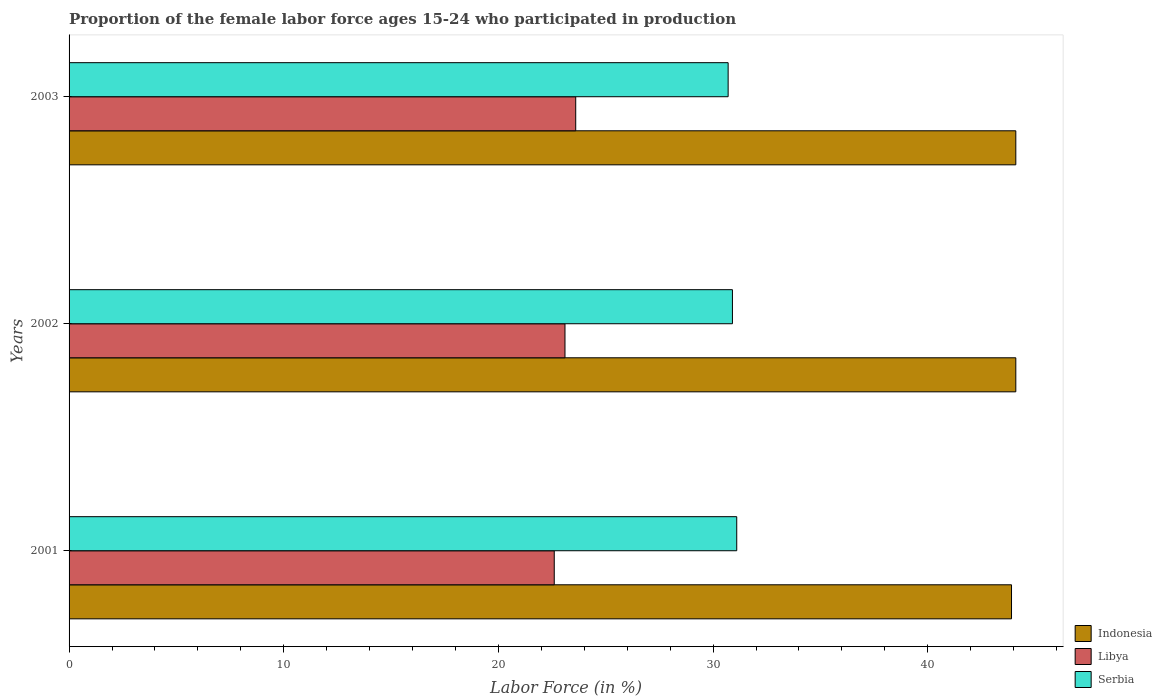How many groups of bars are there?
Provide a succinct answer. 3. Are the number of bars per tick equal to the number of legend labels?
Offer a terse response. Yes. How many bars are there on the 1st tick from the top?
Provide a short and direct response. 3. How many bars are there on the 1st tick from the bottom?
Offer a very short reply. 3. In how many cases, is the number of bars for a given year not equal to the number of legend labels?
Your response must be concise. 0. What is the proportion of the female labor force who participated in production in Libya in 2003?
Keep it short and to the point. 23.6. Across all years, what is the maximum proportion of the female labor force who participated in production in Serbia?
Offer a terse response. 31.1. Across all years, what is the minimum proportion of the female labor force who participated in production in Indonesia?
Your response must be concise. 43.9. In which year was the proportion of the female labor force who participated in production in Libya minimum?
Ensure brevity in your answer.  2001. What is the total proportion of the female labor force who participated in production in Libya in the graph?
Provide a short and direct response. 69.3. What is the difference between the proportion of the female labor force who participated in production in Libya in 2001 and that in 2003?
Provide a short and direct response. -1. What is the difference between the proportion of the female labor force who participated in production in Indonesia in 2001 and the proportion of the female labor force who participated in production in Libya in 2003?
Offer a very short reply. 20.3. What is the average proportion of the female labor force who participated in production in Serbia per year?
Your response must be concise. 30.9. In the year 2002, what is the difference between the proportion of the female labor force who participated in production in Serbia and proportion of the female labor force who participated in production in Indonesia?
Your answer should be very brief. -13.2. What is the ratio of the proportion of the female labor force who participated in production in Indonesia in 2001 to that in 2003?
Offer a very short reply. 1. Is the difference between the proportion of the female labor force who participated in production in Serbia in 2001 and 2003 greater than the difference between the proportion of the female labor force who participated in production in Indonesia in 2001 and 2003?
Ensure brevity in your answer.  Yes. What is the difference between the highest and the lowest proportion of the female labor force who participated in production in Indonesia?
Your response must be concise. 0.2. What does the 3rd bar from the top in 2003 represents?
Provide a short and direct response. Indonesia. What does the 2nd bar from the bottom in 2002 represents?
Ensure brevity in your answer.  Libya. Are all the bars in the graph horizontal?
Make the answer very short. Yes. Are the values on the major ticks of X-axis written in scientific E-notation?
Offer a very short reply. No. Does the graph contain any zero values?
Your answer should be compact. No. Does the graph contain grids?
Provide a succinct answer. No. Where does the legend appear in the graph?
Give a very brief answer. Bottom right. How many legend labels are there?
Your answer should be very brief. 3. How are the legend labels stacked?
Your answer should be very brief. Vertical. What is the title of the graph?
Offer a very short reply. Proportion of the female labor force ages 15-24 who participated in production. What is the label or title of the X-axis?
Keep it short and to the point. Labor Force (in %). What is the Labor Force (in %) of Indonesia in 2001?
Your answer should be very brief. 43.9. What is the Labor Force (in %) in Libya in 2001?
Make the answer very short. 22.6. What is the Labor Force (in %) of Serbia in 2001?
Your answer should be compact. 31.1. What is the Labor Force (in %) of Indonesia in 2002?
Ensure brevity in your answer.  44.1. What is the Labor Force (in %) in Libya in 2002?
Make the answer very short. 23.1. What is the Labor Force (in %) of Serbia in 2002?
Your answer should be compact. 30.9. What is the Labor Force (in %) in Indonesia in 2003?
Ensure brevity in your answer.  44.1. What is the Labor Force (in %) in Libya in 2003?
Offer a very short reply. 23.6. What is the Labor Force (in %) in Serbia in 2003?
Provide a succinct answer. 30.7. Across all years, what is the maximum Labor Force (in %) in Indonesia?
Your answer should be compact. 44.1. Across all years, what is the maximum Labor Force (in %) of Libya?
Your answer should be very brief. 23.6. Across all years, what is the maximum Labor Force (in %) in Serbia?
Your answer should be very brief. 31.1. Across all years, what is the minimum Labor Force (in %) in Indonesia?
Make the answer very short. 43.9. Across all years, what is the minimum Labor Force (in %) in Libya?
Offer a very short reply. 22.6. Across all years, what is the minimum Labor Force (in %) of Serbia?
Your answer should be very brief. 30.7. What is the total Labor Force (in %) in Indonesia in the graph?
Offer a terse response. 132.1. What is the total Labor Force (in %) of Libya in the graph?
Offer a terse response. 69.3. What is the total Labor Force (in %) of Serbia in the graph?
Offer a very short reply. 92.7. What is the difference between the Labor Force (in %) in Indonesia in 2001 and that in 2002?
Ensure brevity in your answer.  -0.2. What is the difference between the Labor Force (in %) of Indonesia in 2001 and that in 2003?
Offer a very short reply. -0.2. What is the difference between the Labor Force (in %) in Libya in 2001 and that in 2003?
Keep it short and to the point. -1. What is the difference between the Labor Force (in %) in Indonesia in 2002 and that in 2003?
Your response must be concise. 0. What is the difference between the Labor Force (in %) in Libya in 2002 and that in 2003?
Offer a terse response. -0.5. What is the difference between the Labor Force (in %) of Indonesia in 2001 and the Labor Force (in %) of Libya in 2002?
Keep it short and to the point. 20.8. What is the difference between the Labor Force (in %) of Libya in 2001 and the Labor Force (in %) of Serbia in 2002?
Give a very brief answer. -8.3. What is the difference between the Labor Force (in %) in Indonesia in 2001 and the Labor Force (in %) in Libya in 2003?
Offer a terse response. 20.3. What is the difference between the Labor Force (in %) in Libya in 2001 and the Labor Force (in %) in Serbia in 2003?
Provide a short and direct response. -8.1. What is the difference between the Labor Force (in %) of Indonesia in 2002 and the Labor Force (in %) of Serbia in 2003?
Offer a very short reply. 13.4. What is the average Labor Force (in %) in Indonesia per year?
Keep it short and to the point. 44.03. What is the average Labor Force (in %) of Libya per year?
Your answer should be very brief. 23.1. What is the average Labor Force (in %) in Serbia per year?
Provide a short and direct response. 30.9. In the year 2001, what is the difference between the Labor Force (in %) in Indonesia and Labor Force (in %) in Libya?
Provide a succinct answer. 21.3. In the year 2001, what is the difference between the Labor Force (in %) of Indonesia and Labor Force (in %) of Serbia?
Your answer should be very brief. 12.8. In the year 2001, what is the difference between the Labor Force (in %) in Libya and Labor Force (in %) in Serbia?
Make the answer very short. -8.5. In the year 2002, what is the difference between the Labor Force (in %) of Indonesia and Labor Force (in %) of Libya?
Ensure brevity in your answer.  21. In the year 2003, what is the difference between the Labor Force (in %) in Indonesia and Labor Force (in %) in Libya?
Give a very brief answer. 20.5. In the year 2003, what is the difference between the Labor Force (in %) of Libya and Labor Force (in %) of Serbia?
Provide a short and direct response. -7.1. What is the ratio of the Labor Force (in %) of Indonesia in 2001 to that in 2002?
Ensure brevity in your answer.  1. What is the ratio of the Labor Force (in %) in Libya in 2001 to that in 2002?
Offer a very short reply. 0.98. What is the ratio of the Labor Force (in %) in Serbia in 2001 to that in 2002?
Your answer should be compact. 1.01. What is the ratio of the Labor Force (in %) of Libya in 2001 to that in 2003?
Ensure brevity in your answer.  0.96. What is the ratio of the Labor Force (in %) of Serbia in 2001 to that in 2003?
Your answer should be very brief. 1.01. What is the ratio of the Labor Force (in %) in Indonesia in 2002 to that in 2003?
Provide a short and direct response. 1. What is the ratio of the Labor Force (in %) in Libya in 2002 to that in 2003?
Ensure brevity in your answer.  0.98. What is the difference between the highest and the second highest Labor Force (in %) in Libya?
Offer a very short reply. 0.5. What is the difference between the highest and the second highest Labor Force (in %) of Serbia?
Your answer should be very brief. 0.2. What is the difference between the highest and the lowest Labor Force (in %) in Libya?
Your answer should be compact. 1. 